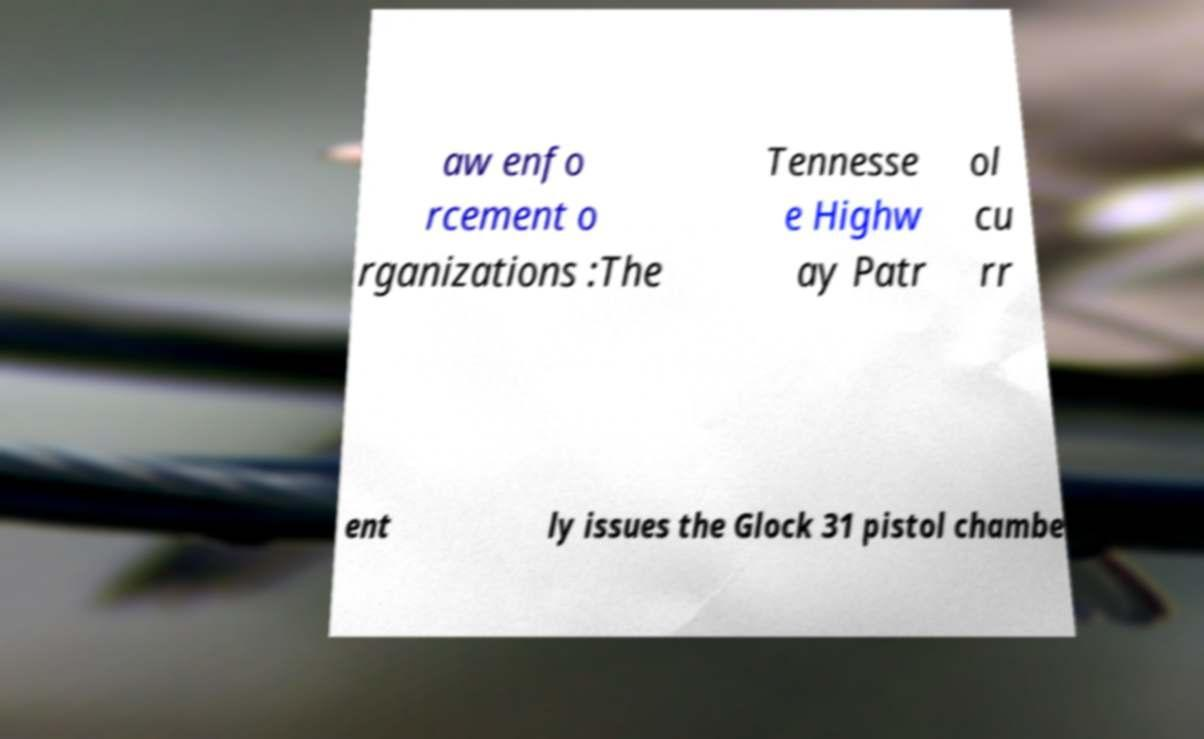Could you extract and type out the text from this image? aw enfo rcement o rganizations :The Tennesse e Highw ay Patr ol cu rr ent ly issues the Glock 31 pistol chambe 